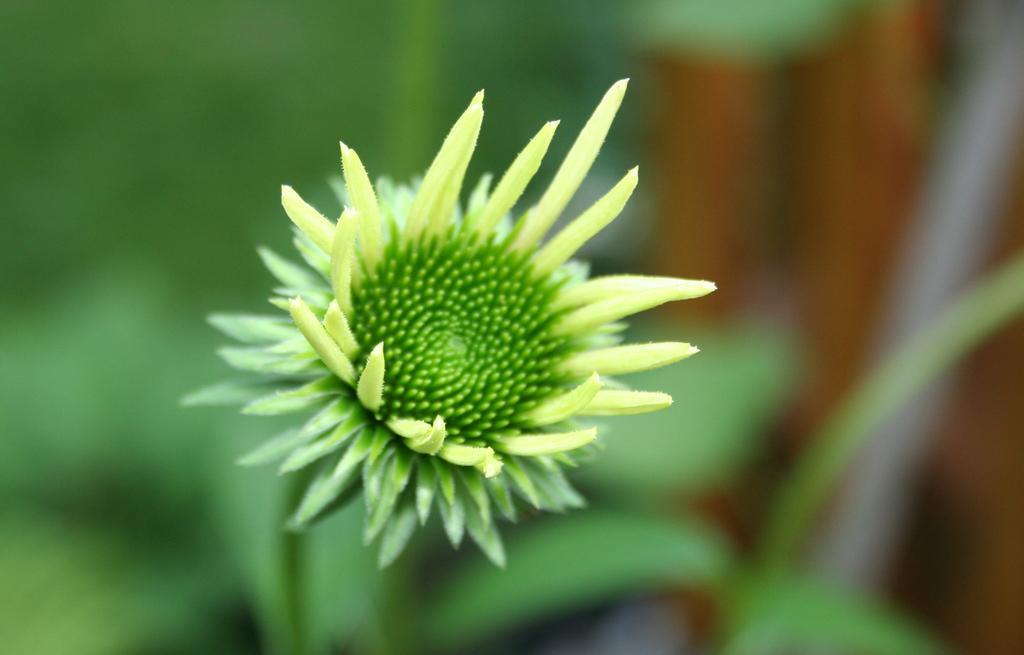How would you summarize this image in a sentence or two? Here I can see a flower which is in green color. The background is blurred. 